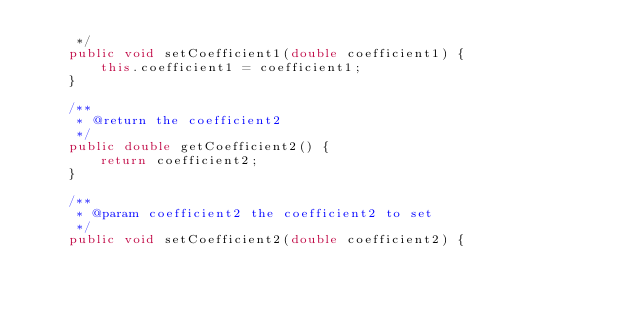Convert code to text. <code><loc_0><loc_0><loc_500><loc_500><_Java_>     */
    public void setCoefficient1(double coefficient1) {
        this.coefficient1 = coefficient1;
    }

    /**
     * @return the coefficient2
     */
    public double getCoefficient2() {
        return coefficient2;
    }

    /**
     * @param coefficient2 the coefficient2 to set
     */
    public void setCoefficient2(double coefficient2) {</code> 